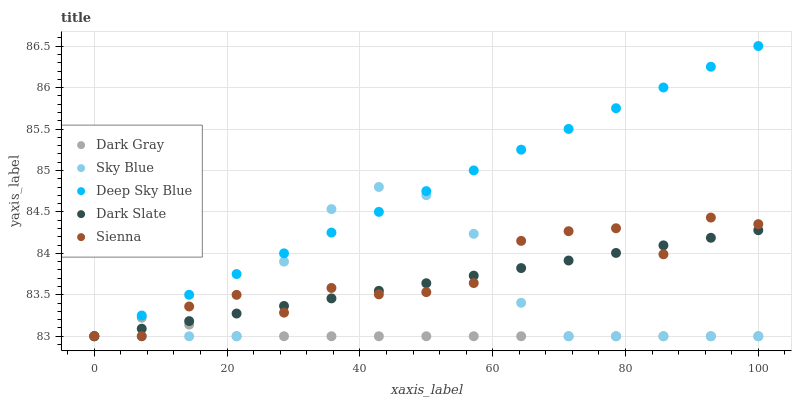Does Dark Gray have the minimum area under the curve?
Answer yes or no. Yes. Does Deep Sky Blue have the maximum area under the curve?
Answer yes or no. Yes. Does Sky Blue have the minimum area under the curve?
Answer yes or no. No. Does Sky Blue have the maximum area under the curve?
Answer yes or no. No. Is Dark Slate the smoothest?
Answer yes or no. Yes. Is Sienna the roughest?
Answer yes or no. Yes. Is Sky Blue the smoothest?
Answer yes or no. No. Is Sky Blue the roughest?
Answer yes or no. No. Does Dark Gray have the lowest value?
Answer yes or no. Yes. Does Deep Sky Blue have the highest value?
Answer yes or no. Yes. Does Sky Blue have the highest value?
Answer yes or no. No. Does Sky Blue intersect Sienna?
Answer yes or no. Yes. Is Sky Blue less than Sienna?
Answer yes or no. No. Is Sky Blue greater than Sienna?
Answer yes or no. No. 